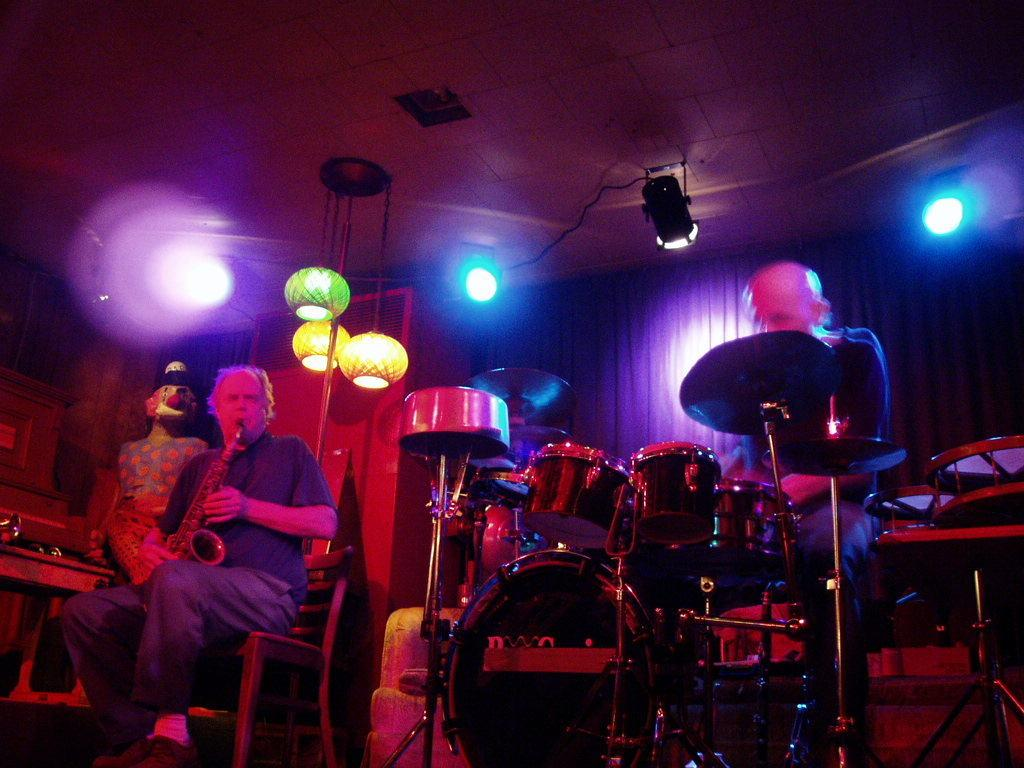What are the people in the image doing? The people in the image are playing musical instruments. Can you describe any additional features in the image? Yes, there are lights on the roof in the image. What type of sleet can be seen falling from the sky in the image? There is no sleet present in the image; it only features people playing musical instruments and lights on the roof. 